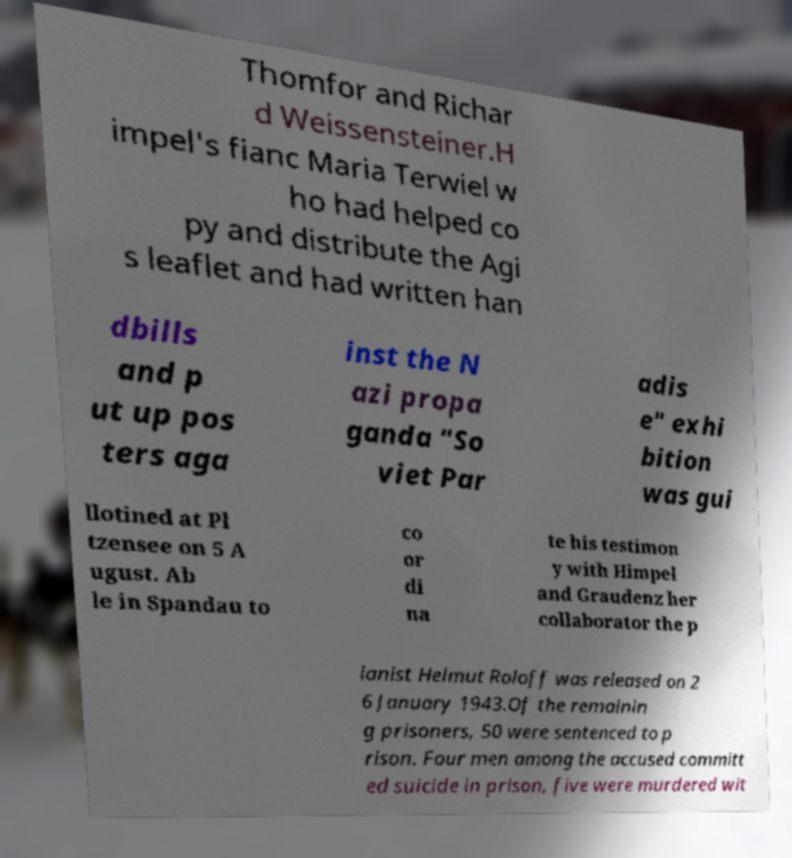For documentation purposes, I need the text within this image transcribed. Could you provide that? Thomfor and Richar d Weissensteiner.H impel's fianc Maria Terwiel w ho had helped co py and distribute the Agi s leaflet and had written han dbills and p ut up pos ters aga inst the N azi propa ganda "So viet Par adis e" exhi bition was gui llotined at Pl tzensee on 5 A ugust. Ab le in Spandau to co or di na te his testimon y with Himpel and Graudenz her collaborator the p ianist Helmut Roloff was released on 2 6 January 1943.Of the remainin g prisoners, 50 were sentenced to p rison. Four men among the accused committ ed suicide in prison, five were murdered wit 